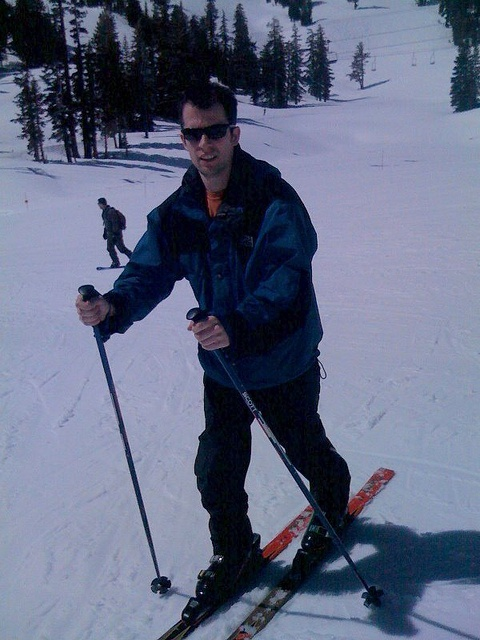Describe the objects in this image and their specific colors. I can see people in black, navy, darkgray, and purple tones, skis in black, gray, maroon, and purple tones, people in black, navy, purple, and gray tones, and skis in black, gray, navy, darkgray, and darkblue tones in this image. 